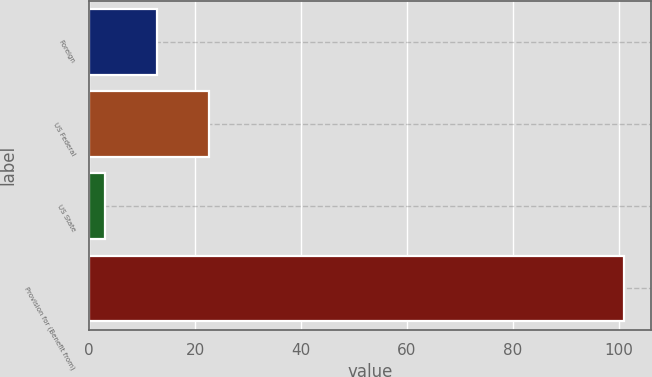<chart> <loc_0><loc_0><loc_500><loc_500><bar_chart><fcel>Foreign<fcel>US Federal<fcel>US State<fcel>Provision for (Benefit from)<nl><fcel>12.8<fcel>22.6<fcel>3<fcel>101<nl></chart> 